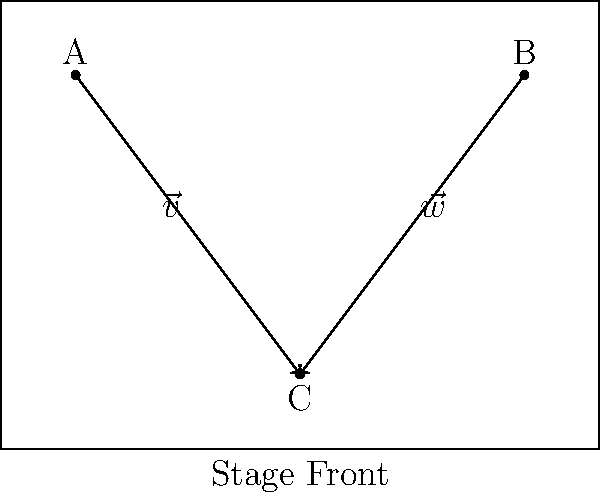Given the stage configuration shown, with lighting positions A, B, and C, calculate the angle between the vectors $\vec{v}$ (from A to C) and $\vec{w}$ (from B to C) to determine the optimal coverage angle for the lighting rig. How many degrees should the angle between these two vectors be for balanced stage illumination? To find the angle between vectors $\vec{v}$ and $\vec{w}$, we'll follow these steps:

1. Calculate the components of vectors $\vec{v}$ and $\vec{w}$:
   $\vec{v} = C - A = (0, -2) - (-3, 2) = (3, -4)$
   $\vec{w} = C - B = (0, -2) - (3, 2) = (-3, -4)$

2. Use the dot product formula to find the angle:
   $\cos \theta = \frac{\vec{v} \cdot \vec{w}}{|\vec{v}||\vec{w}|}$

3. Calculate the dot product:
   $\vec{v} \cdot \vec{w} = (3)(-3) + (-4)(-4) = -9 + 16 = 7$

4. Calculate the magnitudes:
   $|\vec{v}| = \sqrt{3^2 + (-4)^2} = \sqrt{25} = 5$
   $|\vec{w}| = \sqrt{(-3)^2 + (-4)^2} = \sqrt{25} = 5$

5. Substitute into the formula:
   $\cos \theta = \frac{7}{5 \cdot 5} = \frac{7}{25}$

6. Take the inverse cosine (arccos) to find the angle:
   $\theta = \arccos(\frac{7}{25}) \approx 1.204$ radians

7. Convert to degrees:
   $\theta \approx 1.204 \cdot \frac{180}{\pi} \approx 69.0°$

The angle between the two vectors is approximately 69.0°, which provides a balanced coverage for stage illumination.
Answer: 69.0° 